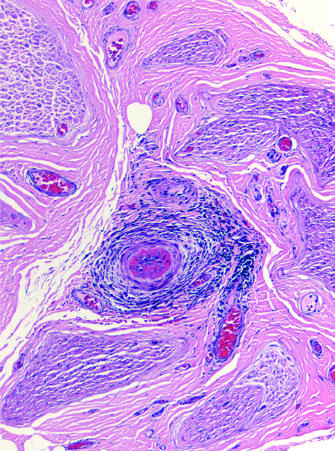what contains an inflammatory infiltrate around small blood vessels that has obliterated a vessel in b?
Answer the question using a single word or phrase. The perineurial connective tissue 